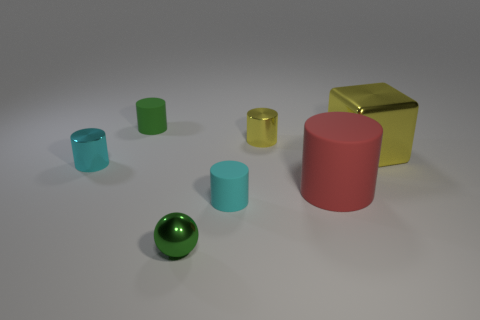Subtract all small green rubber cylinders. How many cylinders are left? 4 Subtract 2 cylinders. How many cylinders are left? 3 Subtract all green cylinders. How many cylinders are left? 4 Subtract all purple cylinders. Subtract all brown spheres. How many cylinders are left? 5 Add 1 tiny metal things. How many objects exist? 8 Subtract all cylinders. How many objects are left? 2 Subtract 0 red cubes. How many objects are left? 7 Subtract all tiny gray metal balls. Subtract all large metallic cubes. How many objects are left? 6 Add 1 small cyan shiny cylinders. How many small cyan shiny cylinders are left? 2 Add 6 large yellow things. How many large yellow things exist? 7 